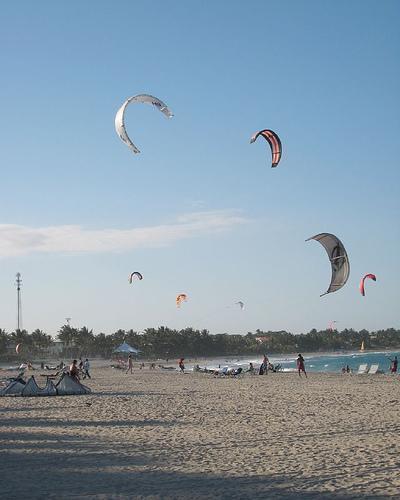How many kites can be seen?
Give a very brief answer. 7. How many giraffes are not reaching towards the woman?
Give a very brief answer. 0. 